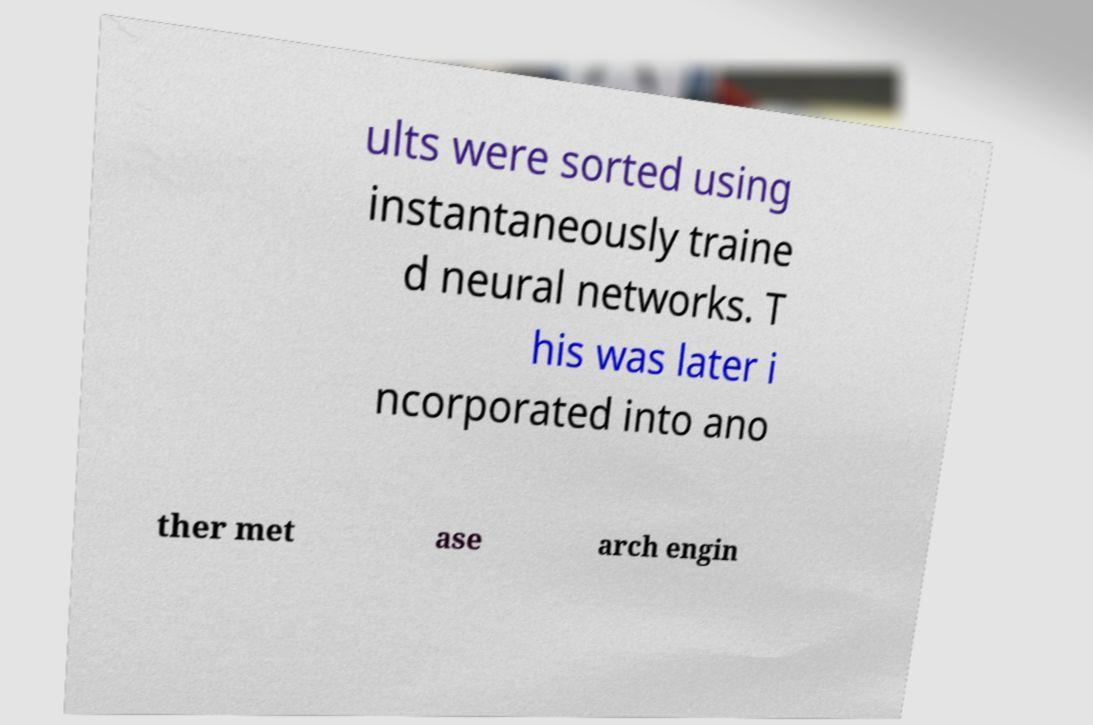Could you extract and type out the text from this image? ults were sorted using instantaneously traine d neural networks. T his was later i ncorporated into ano ther met ase arch engin 